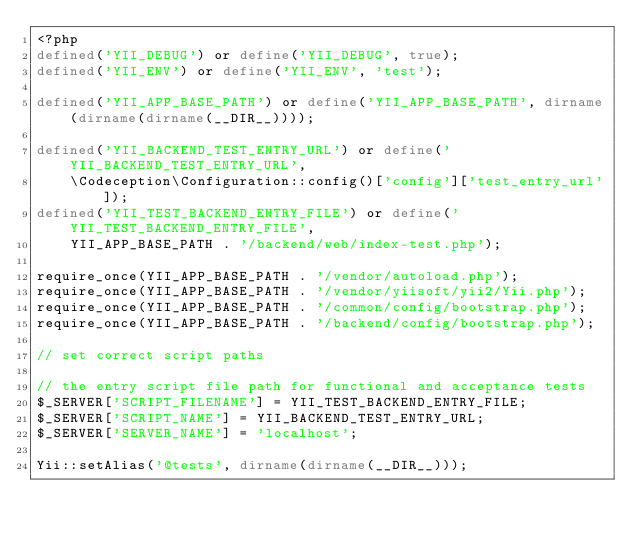Convert code to text. <code><loc_0><loc_0><loc_500><loc_500><_PHP_><?php
defined('YII_DEBUG') or define('YII_DEBUG', true);
defined('YII_ENV') or define('YII_ENV', 'test');

defined('YII_APP_BASE_PATH') or define('YII_APP_BASE_PATH', dirname(dirname(dirname(__DIR__))));

defined('YII_BACKEND_TEST_ENTRY_URL') or define('YII_BACKEND_TEST_ENTRY_URL',
    \Codeception\Configuration::config()['config']['test_entry_url']);
defined('YII_TEST_BACKEND_ENTRY_FILE') or define('YII_TEST_BACKEND_ENTRY_FILE',
    YII_APP_BASE_PATH . '/backend/web/index-test.php');

require_once(YII_APP_BASE_PATH . '/vendor/autoload.php');
require_once(YII_APP_BASE_PATH . '/vendor/yiisoft/yii2/Yii.php');
require_once(YII_APP_BASE_PATH . '/common/config/bootstrap.php');
require_once(YII_APP_BASE_PATH . '/backend/config/bootstrap.php');

// set correct script paths

// the entry script file path for functional and acceptance tests
$_SERVER['SCRIPT_FILENAME'] = YII_TEST_BACKEND_ENTRY_FILE;
$_SERVER['SCRIPT_NAME'] = YII_BACKEND_TEST_ENTRY_URL;
$_SERVER['SERVER_NAME'] = 'localhost';

Yii::setAlias('@tests', dirname(dirname(__DIR__)));
</code> 